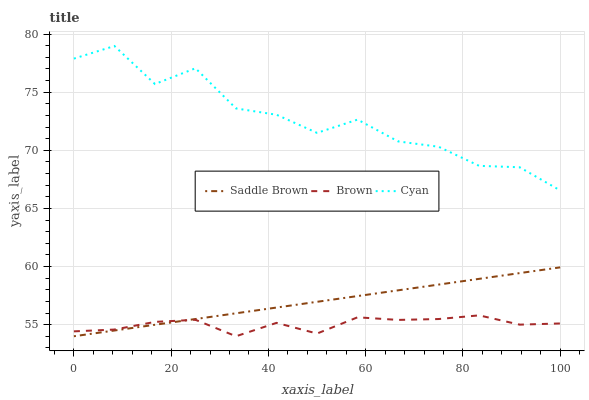Does Saddle Brown have the minimum area under the curve?
Answer yes or no. No. Does Saddle Brown have the maximum area under the curve?
Answer yes or no. No. Is Cyan the smoothest?
Answer yes or no. No. Is Saddle Brown the roughest?
Answer yes or no. No. Does Cyan have the lowest value?
Answer yes or no. No. Does Saddle Brown have the highest value?
Answer yes or no. No. Is Brown less than Cyan?
Answer yes or no. Yes. Is Cyan greater than Saddle Brown?
Answer yes or no. Yes. Does Brown intersect Cyan?
Answer yes or no. No. 